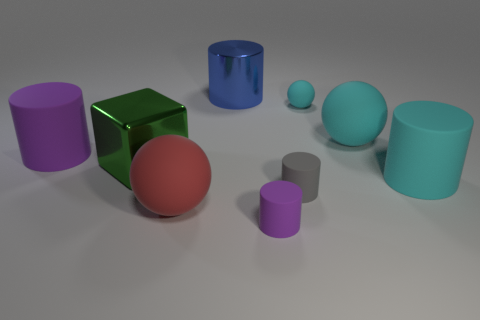Can you describe the spatial arrangement of the objects in the image? Certainly! The image shows various geometric shapes, including cylinders and spheres, arranged on a flat surface. A medium-sized purple cylinder is positioned behind a tiny grey cylinder in the foreground. To the right, there's a large teal sphere and a medium turquoise cylinder, suggesting a deliberate composition with a mix of sizes and colors. 